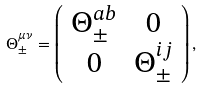Convert formula to latex. <formula><loc_0><loc_0><loc_500><loc_500>\Theta ^ { \mu \nu } _ { \pm } = \left ( \begin{array} { c c } \Theta ^ { a b } _ { \pm } & 0 \\ 0 & \Theta ^ { i j } _ { \pm } \end{array} \right ) ,</formula> 